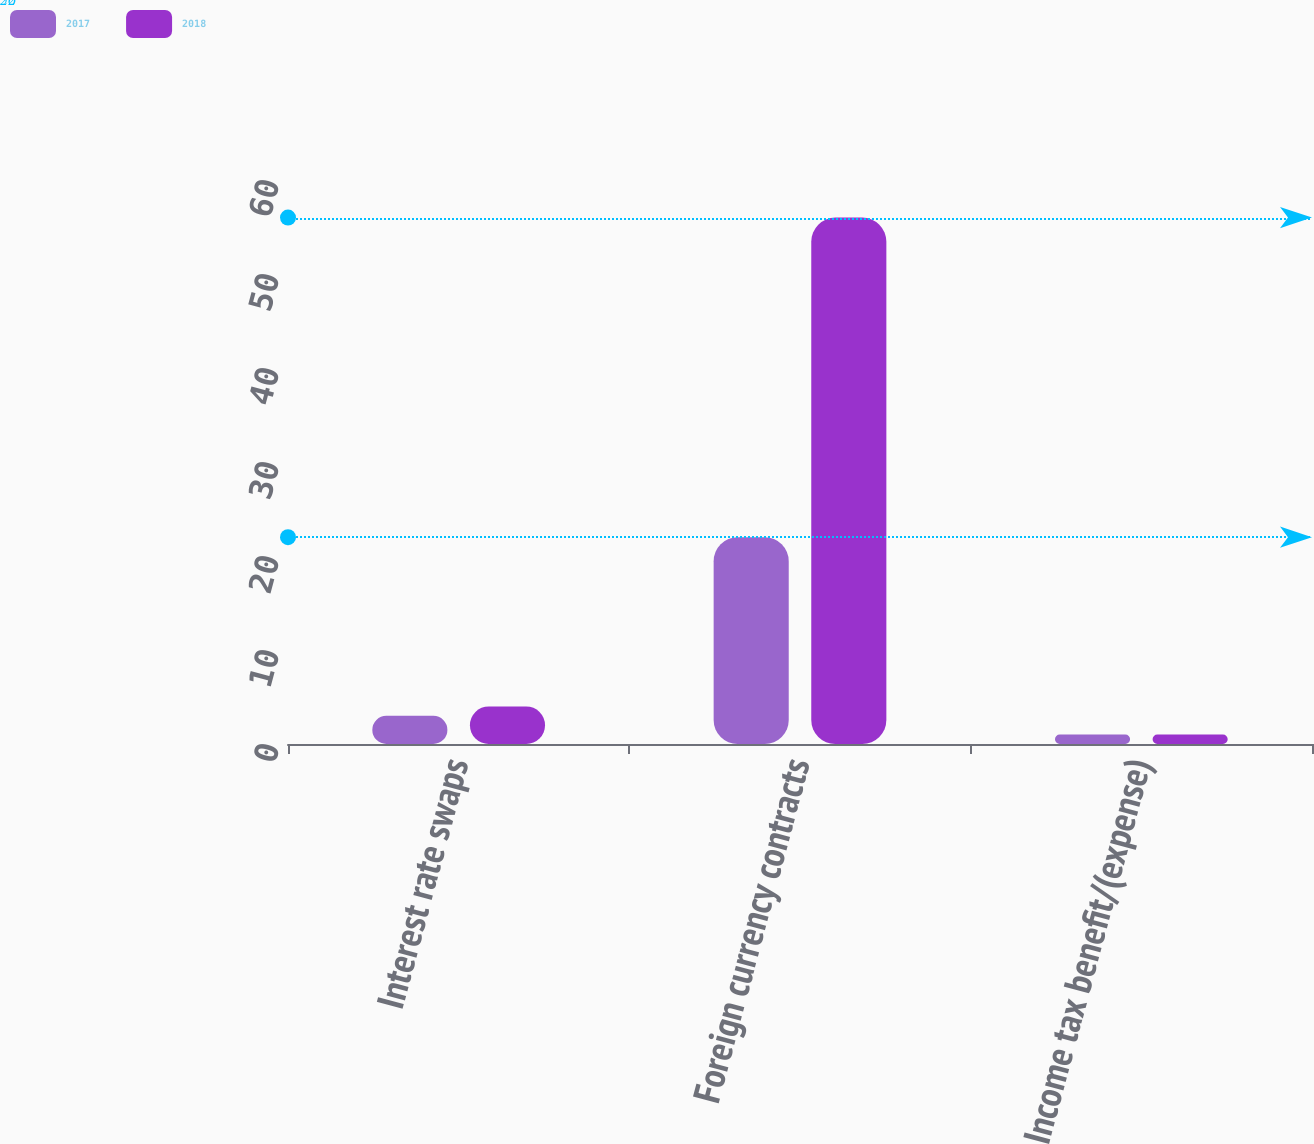<chart> <loc_0><loc_0><loc_500><loc_500><stacked_bar_chart><ecel><fcel>Interest rate swaps<fcel>Foreign currency contracts<fcel>Income tax benefit/(expense)<nl><fcel>2017<fcel>3<fcel>22<fcel>1<nl><fcel>2018<fcel>4<fcel>56<fcel>1<nl></chart> 